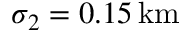Convert formula to latex. <formula><loc_0><loc_0><loc_500><loc_500>\sigma _ { 2 } = 0 . 1 5 \, k m</formula> 